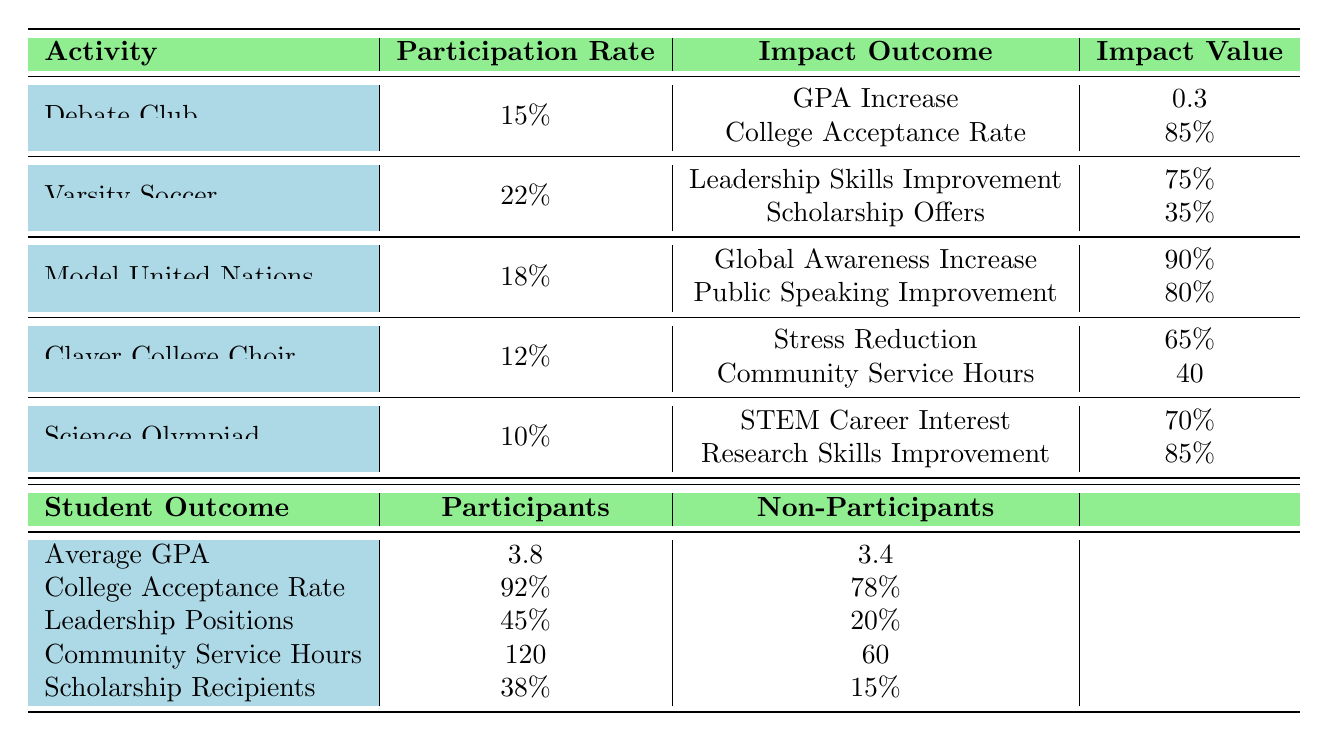What is the participation rate for Debate Club? The participation rate for Debate Club is specifically listed in the table under the "Participation Rate" column, where it states 15%.
Answer: 15% Which extracurricular activity has the highest participation rate? By comparing the participation rates in the table, Varsity Soccer has the highest participation rate at 22%.
Answer: Varsity Soccer What is the impact value of the GPA Increase from the Debate Club? The table lists GPA Increase as an impact of the Debate Club with a specific value of 0.3 under the "Impact Value" column.
Answer: 0.3 Do participants in extracurricular activities have a higher average GPA compared to non-participants? The table provides average GPAs for both participants (3.8) and non-participants (3.4). Since 3.8 is greater than 3.4, participants indeed have a higher average GPA.
Answer: Yes What is the difference in College Acceptance Rate between participants and non-participants? The College Acceptance Rate for participants is 92%, while for non-participants, it is 78%. The difference is calculated as 92% - 78% = 14%.
Answer: 14% Which activity improves Global Awareness the most based on its impact value? The activity with the highest impact value for Global Awareness is Model United Nations, with an impact value of 0.9 as seen in the table.
Answer: Model United Nations How many more community service hours do participants accumulate compared to non-participants? In the table, participants have 120 community service hours while non-participants have 60. The difference is 120 - 60 = 60 hours.
Answer: 60 hours Is the improvement in Leadership Skills from Varsity Soccer greater than the increase in GPA from Debate Club? The impact of Leadership Skills Improvement from Varsity Soccer is listed at 75%, while the GPA Increase from Debate Club is at 30%. Thus, 75% is greater than 30%.
Answer: Yes What percentage of participants are scholarship recipients? The table shows that 38% of participants are scholarship recipients under the "Scholarship Recipients" outcome.
Answer: 38% How would you summarize the difference in research skills improvement between participants in Science Olympiad and non-participants overall? Research Skills Improvement for Science Olympiad participants is 85%, while overall non-participants do not have a specified value for this skill, so we conclude that participants in Science Olympiad significantly benefit.
Answer: Significant improvement for participants 